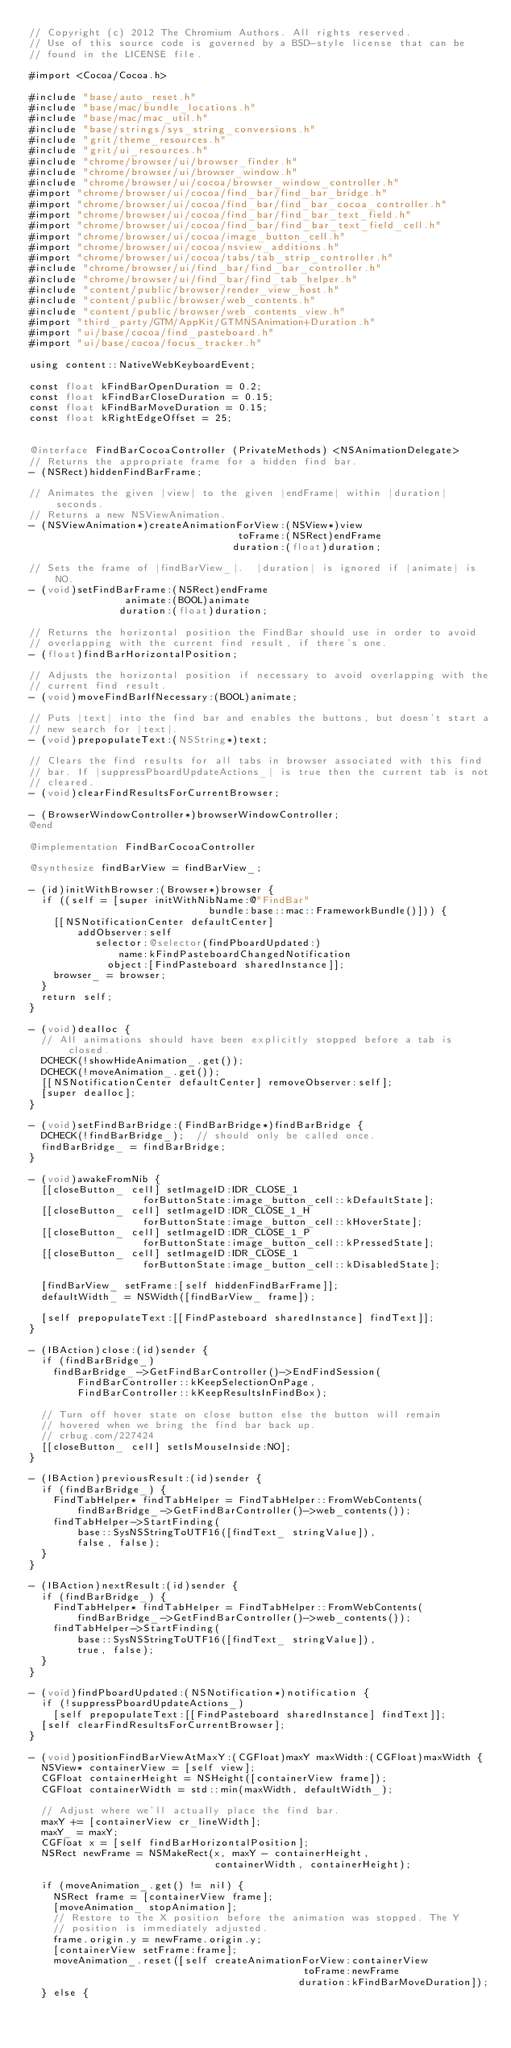Convert code to text. <code><loc_0><loc_0><loc_500><loc_500><_ObjectiveC_>// Copyright (c) 2012 The Chromium Authors. All rights reserved.
// Use of this source code is governed by a BSD-style license that can be
// found in the LICENSE file.

#import <Cocoa/Cocoa.h>

#include "base/auto_reset.h"
#include "base/mac/bundle_locations.h"
#include "base/mac/mac_util.h"
#include "base/strings/sys_string_conversions.h"
#include "grit/theme_resources.h"
#include "grit/ui_resources.h"
#include "chrome/browser/ui/browser_finder.h"
#include "chrome/browser/ui/browser_window.h"
#include "chrome/browser/ui/cocoa/browser_window_controller.h"
#import "chrome/browser/ui/cocoa/find_bar/find_bar_bridge.h"
#import "chrome/browser/ui/cocoa/find_bar/find_bar_cocoa_controller.h"
#import "chrome/browser/ui/cocoa/find_bar/find_bar_text_field.h"
#import "chrome/browser/ui/cocoa/find_bar/find_bar_text_field_cell.h"
#import "chrome/browser/ui/cocoa/image_button_cell.h"
#import "chrome/browser/ui/cocoa/nsview_additions.h"
#import "chrome/browser/ui/cocoa/tabs/tab_strip_controller.h"
#include "chrome/browser/ui/find_bar/find_bar_controller.h"
#include "chrome/browser/ui/find_bar/find_tab_helper.h"
#include "content/public/browser/render_view_host.h"
#include "content/public/browser/web_contents.h"
#include "content/public/browser/web_contents_view.h"
#import "third_party/GTM/AppKit/GTMNSAnimation+Duration.h"
#import "ui/base/cocoa/find_pasteboard.h"
#import "ui/base/cocoa/focus_tracker.h"

using content::NativeWebKeyboardEvent;

const float kFindBarOpenDuration = 0.2;
const float kFindBarCloseDuration = 0.15;
const float kFindBarMoveDuration = 0.15;
const float kRightEdgeOffset = 25;


@interface FindBarCocoaController (PrivateMethods) <NSAnimationDelegate>
// Returns the appropriate frame for a hidden find bar.
- (NSRect)hiddenFindBarFrame;

// Animates the given |view| to the given |endFrame| within |duration| seconds.
// Returns a new NSViewAnimation.
- (NSViewAnimation*)createAnimationForView:(NSView*)view
                                   toFrame:(NSRect)endFrame
                                  duration:(float)duration;

// Sets the frame of |findBarView_|.  |duration| is ignored if |animate| is NO.
- (void)setFindBarFrame:(NSRect)endFrame
                animate:(BOOL)animate
               duration:(float)duration;

// Returns the horizontal position the FindBar should use in order to avoid
// overlapping with the current find result, if there's one.
- (float)findBarHorizontalPosition;

// Adjusts the horizontal position if necessary to avoid overlapping with the
// current find result.
- (void)moveFindBarIfNecessary:(BOOL)animate;

// Puts |text| into the find bar and enables the buttons, but doesn't start a
// new search for |text|.
- (void)prepopulateText:(NSString*)text;

// Clears the find results for all tabs in browser associated with this find
// bar. If |suppressPboardUpdateActions_| is true then the current tab is not
// cleared.
- (void)clearFindResultsForCurrentBrowser;

- (BrowserWindowController*)browserWindowController;
@end

@implementation FindBarCocoaController

@synthesize findBarView = findBarView_;

- (id)initWithBrowser:(Browser*)browser {
  if ((self = [super initWithNibName:@"FindBar"
                              bundle:base::mac::FrameworkBundle()])) {
    [[NSNotificationCenter defaultCenter]
        addObserver:self
           selector:@selector(findPboardUpdated:)
               name:kFindPasteboardChangedNotification
             object:[FindPasteboard sharedInstance]];
    browser_ = browser;
  }
  return self;
}

- (void)dealloc {
  // All animations should have been explicitly stopped before a tab is closed.
  DCHECK(!showHideAnimation_.get());
  DCHECK(!moveAnimation_.get());
  [[NSNotificationCenter defaultCenter] removeObserver:self];
  [super dealloc];
}

- (void)setFindBarBridge:(FindBarBridge*)findBarBridge {
  DCHECK(!findBarBridge_);  // should only be called once.
  findBarBridge_ = findBarBridge;
}

- (void)awakeFromNib {
  [[closeButton_ cell] setImageID:IDR_CLOSE_1
                   forButtonState:image_button_cell::kDefaultState];
  [[closeButton_ cell] setImageID:IDR_CLOSE_1_H
                   forButtonState:image_button_cell::kHoverState];
  [[closeButton_ cell] setImageID:IDR_CLOSE_1_P
                   forButtonState:image_button_cell::kPressedState];
  [[closeButton_ cell] setImageID:IDR_CLOSE_1
                   forButtonState:image_button_cell::kDisabledState];

  [findBarView_ setFrame:[self hiddenFindBarFrame]];
  defaultWidth_ = NSWidth([findBarView_ frame]);

  [self prepopulateText:[[FindPasteboard sharedInstance] findText]];
}

- (IBAction)close:(id)sender {
  if (findBarBridge_)
    findBarBridge_->GetFindBarController()->EndFindSession(
        FindBarController::kKeepSelectionOnPage,
        FindBarController::kKeepResultsInFindBox);

  // Turn off hover state on close button else the button will remain
  // hovered when we bring the find bar back up.
  // crbug.com/227424
  [[closeButton_ cell] setIsMouseInside:NO];
}

- (IBAction)previousResult:(id)sender {
  if (findBarBridge_) {
    FindTabHelper* findTabHelper = FindTabHelper::FromWebContents(
        findBarBridge_->GetFindBarController()->web_contents());
    findTabHelper->StartFinding(
        base::SysNSStringToUTF16([findText_ stringValue]),
        false, false);
  }
}

- (IBAction)nextResult:(id)sender {
  if (findBarBridge_) {
    FindTabHelper* findTabHelper = FindTabHelper::FromWebContents(
        findBarBridge_->GetFindBarController()->web_contents());
    findTabHelper->StartFinding(
        base::SysNSStringToUTF16([findText_ stringValue]),
        true, false);
  }
}

- (void)findPboardUpdated:(NSNotification*)notification {
  if (!suppressPboardUpdateActions_)
    [self prepopulateText:[[FindPasteboard sharedInstance] findText]];
  [self clearFindResultsForCurrentBrowser];
}

- (void)positionFindBarViewAtMaxY:(CGFloat)maxY maxWidth:(CGFloat)maxWidth {
  NSView* containerView = [self view];
  CGFloat containerHeight = NSHeight([containerView frame]);
  CGFloat containerWidth = std::min(maxWidth, defaultWidth_);

  // Adjust where we'll actually place the find bar.
  maxY += [containerView cr_lineWidth];
  maxY_ = maxY;
  CGFloat x = [self findBarHorizontalPosition];
  NSRect newFrame = NSMakeRect(x, maxY - containerHeight,
                               containerWidth, containerHeight);

  if (moveAnimation_.get() != nil) {
    NSRect frame = [containerView frame];
    [moveAnimation_ stopAnimation];
    // Restore to the X position before the animation was stopped. The Y
    // position is immediately adjusted.
    frame.origin.y = newFrame.origin.y;
    [containerView setFrame:frame];
    moveAnimation_.reset([self createAnimationForView:containerView
                                              toFrame:newFrame
                                             duration:kFindBarMoveDuration]);
  } else {</code> 